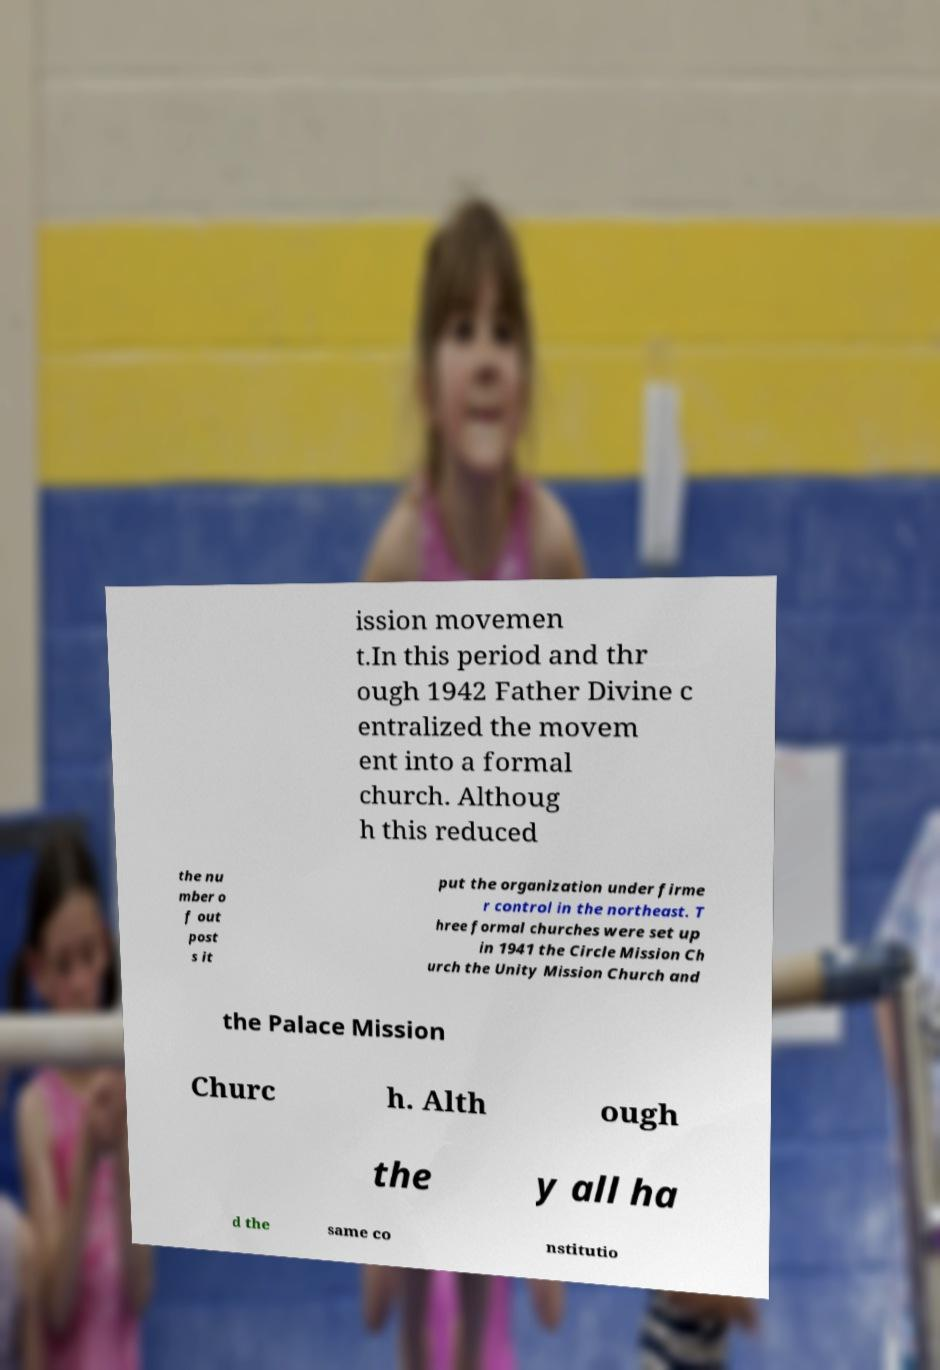I need the written content from this picture converted into text. Can you do that? ission movemen t.In this period and thr ough 1942 Father Divine c entralized the movem ent into a formal church. Althoug h this reduced the nu mber o f out post s it put the organization under firme r control in the northeast. T hree formal churches were set up in 1941 the Circle Mission Ch urch the Unity Mission Church and the Palace Mission Churc h. Alth ough the y all ha d the same co nstitutio 